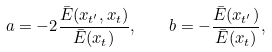Convert formula to latex. <formula><loc_0><loc_0><loc_500><loc_500>a = - 2 \frac { \bar { E } ( x _ { t ^ { \prime } } , x _ { t } ) } { \bar { E } ( x _ { t } ) } , \quad b = - \frac { \bar { E } ( x _ { t ^ { \prime } } ) } { \bar { E } ( x _ { t } ) } ,</formula> 